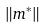Convert formula to latex. <formula><loc_0><loc_0><loc_500><loc_500>\| m ^ { * } \|</formula> 